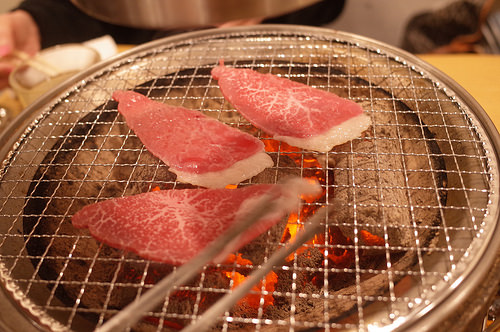<image>
Can you confirm if the steak is above the table? Yes. The steak is positioned above the table in the vertical space, higher up in the scene. 